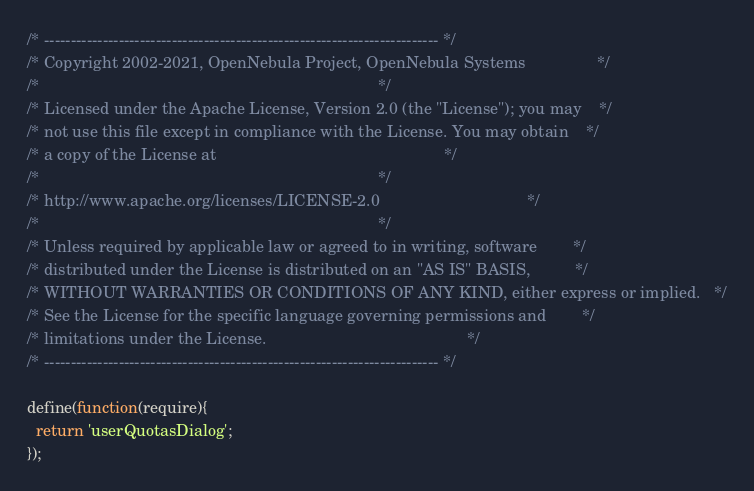Convert code to text. <code><loc_0><loc_0><loc_500><loc_500><_JavaScript_>/* -------------------------------------------------------------------------- */
/* Copyright 2002-2021, OpenNebula Project, OpenNebula Systems                */
/*                                                                            */
/* Licensed under the Apache License, Version 2.0 (the "License"); you may    */
/* not use this file except in compliance with the License. You may obtain    */
/* a copy of the License at                                                   */
/*                                                                            */
/* http://www.apache.org/licenses/LICENSE-2.0                                 */
/*                                                                            */
/* Unless required by applicable law or agreed to in writing, software        */
/* distributed under the License is distributed on an "AS IS" BASIS,          */
/* WITHOUT WARRANTIES OR CONDITIONS OF ANY KIND, either express or implied.   */
/* See the License for the specific language governing permissions and        */
/* limitations under the License.                                             */
/* -------------------------------------------------------------------------- */

define(function(require){
  return 'userQuotasDialog';
});
</code> 